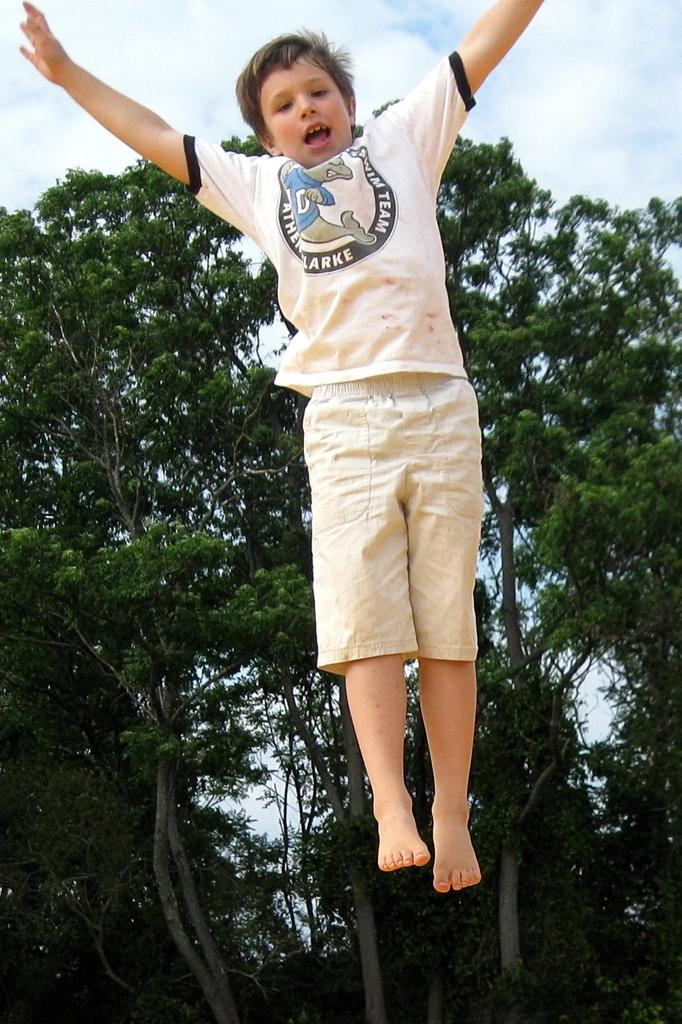What is the main subject of the image? The main subject of the image is a boy in the air. What can be seen in the background of the image? There are trees and the sky visible in the background of the image. What is the condition of the sky in the image? Clouds are present in the sky. What type of government is depicted in the image? There is no depiction of a government in the image; it features a boy in the air with trees and clouds in the background. What effect does the government have on the boy in the image? There is no government present in the image, and therefore no effect on the boy can be observed. 